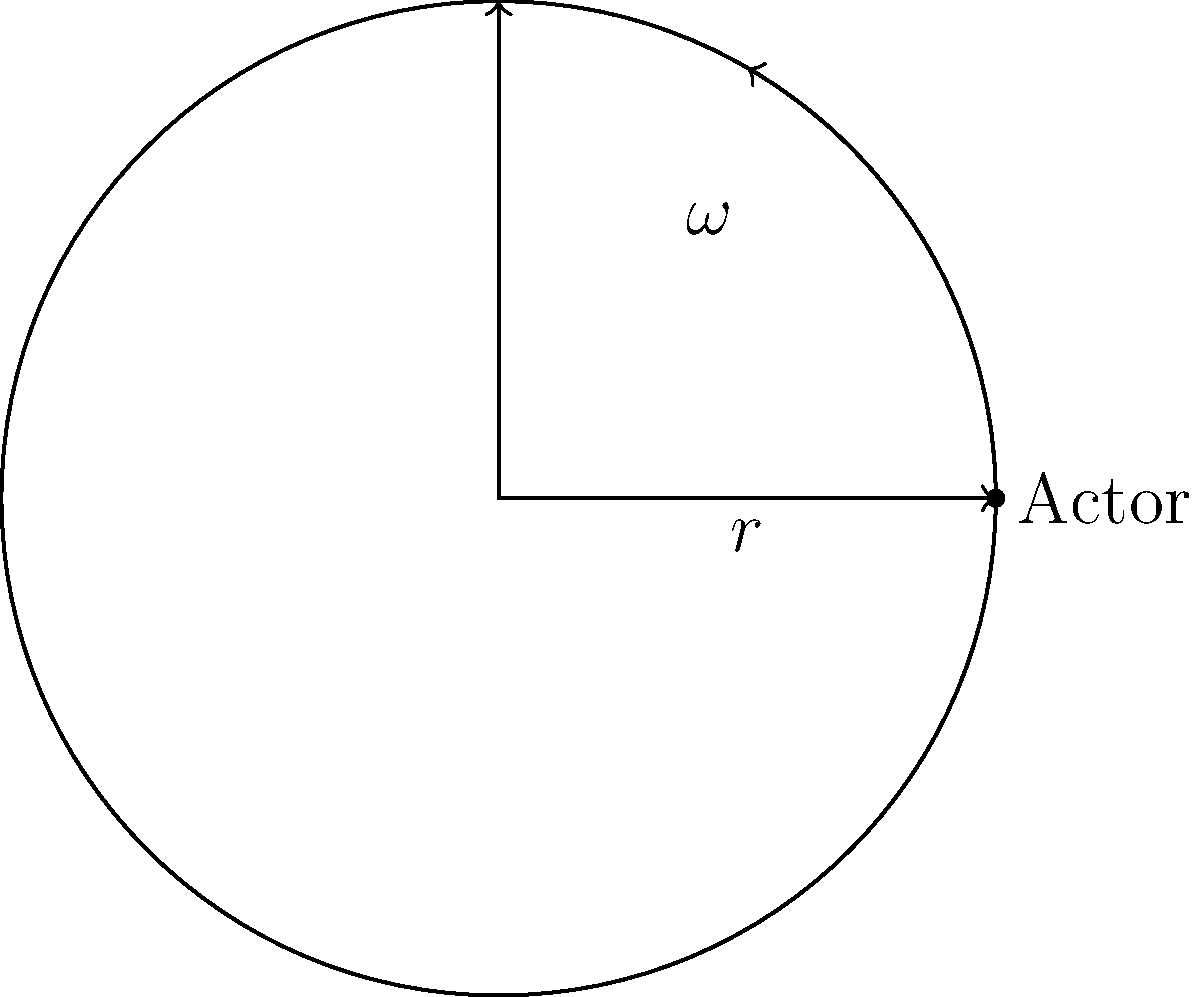As a production assistant, you're working on a film with a rotating set piece. An actor weighing 70 kg is standing at the edge of a circular platform with a radius of 3 meters, rotating at 2 radians per second. What is the centripetal force experienced by the actor? To calculate the centripetal force, we'll use the formula:

$$F_c = m\omega^2r$$

Where:
$F_c$ is the centripetal force
$m$ is the mass of the actor
$\omega$ is the angular velocity
$r$ is the radius of the circular path

Step 1: Identify the given values
- Mass (m) = 70 kg
- Angular velocity (ω) = 2 rad/s
- Radius (r) = 3 m

Step 2: Substitute the values into the formula
$$F_c = 70 \text{ kg} \cdot (2 \text{ rad/s})^2 \cdot 3 \text{ m}$$

Step 3: Calculate
$$F_c = 70 \cdot 4 \cdot 3 = 840 \text{ N}$$

Therefore, the centripetal force experienced by the actor is 840 Newtons.
Answer: 840 N 